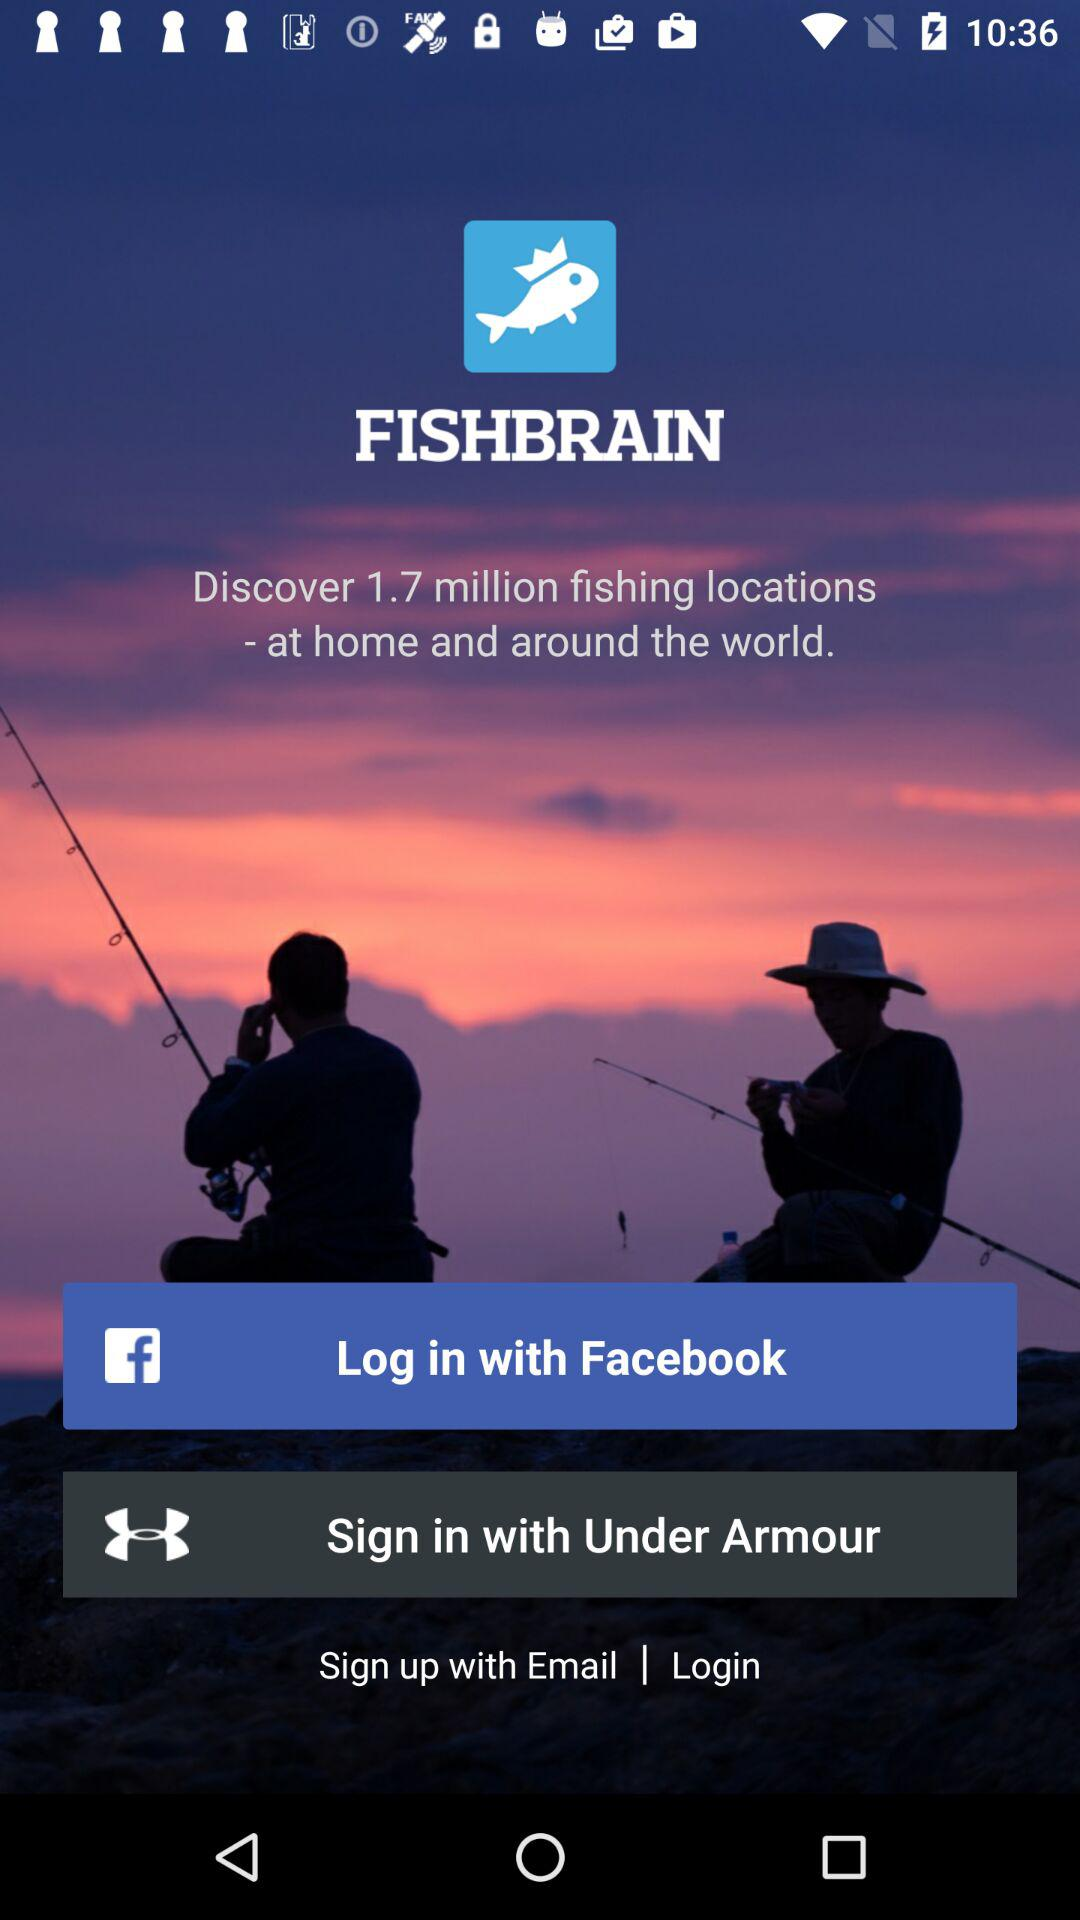What is the name of the application? The name of the application is "FISHBRAIN". 